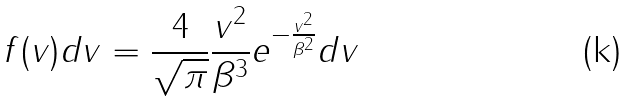<formula> <loc_0><loc_0><loc_500><loc_500>f ( v ) d v = \frac { 4 } { \sqrt { \pi } } \frac { v ^ { 2 } } { \beta ^ { 3 } } e ^ { - \frac { v ^ { 2 } } { \beta ^ { 2 } } } d v</formula> 